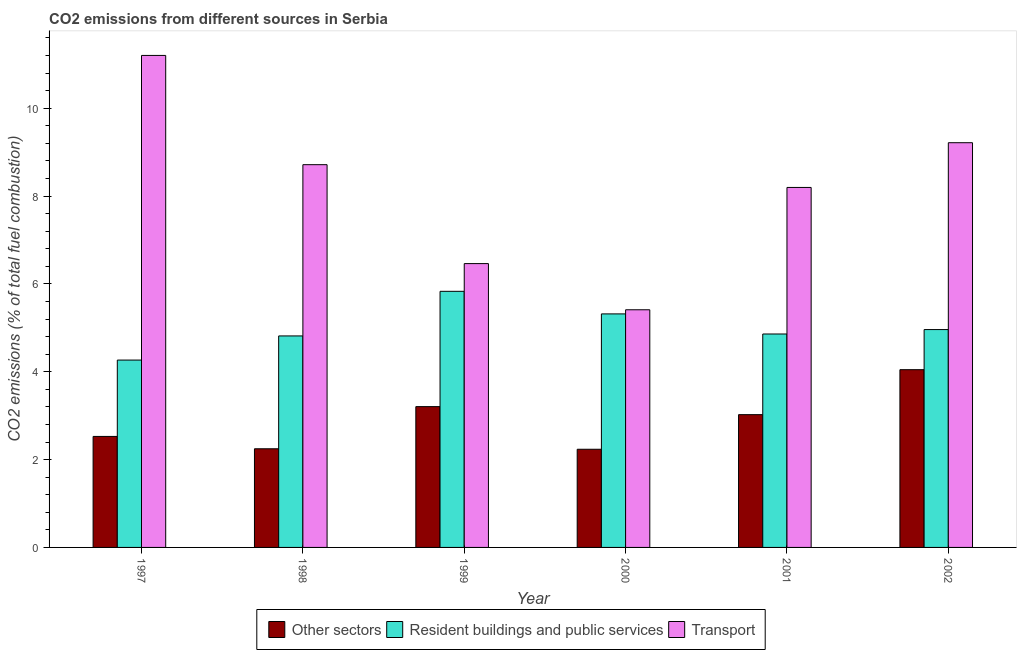Are the number of bars on each tick of the X-axis equal?
Keep it short and to the point. Yes. How many bars are there on the 6th tick from the left?
Your response must be concise. 3. How many bars are there on the 4th tick from the right?
Keep it short and to the point. 3. What is the label of the 1st group of bars from the left?
Provide a short and direct response. 1997. In how many cases, is the number of bars for a given year not equal to the number of legend labels?
Ensure brevity in your answer.  0. What is the percentage of co2 emissions from resident buildings and public services in 1999?
Provide a short and direct response. 5.83. Across all years, what is the maximum percentage of co2 emissions from resident buildings and public services?
Offer a terse response. 5.83. Across all years, what is the minimum percentage of co2 emissions from transport?
Ensure brevity in your answer.  5.41. In which year was the percentage of co2 emissions from transport maximum?
Ensure brevity in your answer.  1997. What is the total percentage of co2 emissions from other sectors in the graph?
Your answer should be very brief. 17.28. What is the difference between the percentage of co2 emissions from transport in 2000 and that in 2002?
Make the answer very short. -3.8. What is the difference between the percentage of co2 emissions from other sectors in 2000 and the percentage of co2 emissions from transport in 2002?
Make the answer very short. -1.81. What is the average percentage of co2 emissions from transport per year?
Offer a terse response. 8.2. In the year 2001, what is the difference between the percentage of co2 emissions from transport and percentage of co2 emissions from resident buildings and public services?
Provide a succinct answer. 0. In how many years, is the percentage of co2 emissions from resident buildings and public services greater than 1.6 %?
Offer a terse response. 6. What is the ratio of the percentage of co2 emissions from resident buildings and public services in 1998 to that in 2000?
Provide a short and direct response. 0.91. What is the difference between the highest and the second highest percentage of co2 emissions from transport?
Keep it short and to the point. 1.99. What is the difference between the highest and the lowest percentage of co2 emissions from resident buildings and public services?
Ensure brevity in your answer.  1.57. Is the sum of the percentage of co2 emissions from resident buildings and public services in 1997 and 2000 greater than the maximum percentage of co2 emissions from other sectors across all years?
Offer a terse response. Yes. What does the 2nd bar from the left in 2001 represents?
Offer a terse response. Resident buildings and public services. What does the 1st bar from the right in 1999 represents?
Ensure brevity in your answer.  Transport. Is it the case that in every year, the sum of the percentage of co2 emissions from other sectors and percentage of co2 emissions from resident buildings and public services is greater than the percentage of co2 emissions from transport?
Provide a short and direct response. No. How many bars are there?
Provide a succinct answer. 18. How many years are there in the graph?
Your answer should be compact. 6. Does the graph contain any zero values?
Make the answer very short. No. Where does the legend appear in the graph?
Keep it short and to the point. Bottom center. How many legend labels are there?
Make the answer very short. 3. What is the title of the graph?
Your answer should be compact. CO2 emissions from different sources in Serbia. What is the label or title of the X-axis?
Give a very brief answer. Year. What is the label or title of the Y-axis?
Make the answer very short. CO2 emissions (% of total fuel combustion). What is the CO2 emissions (% of total fuel combustion) of Other sectors in 1997?
Provide a short and direct response. 2.53. What is the CO2 emissions (% of total fuel combustion) of Resident buildings and public services in 1997?
Keep it short and to the point. 4.27. What is the CO2 emissions (% of total fuel combustion) of Transport in 1997?
Offer a terse response. 11.2. What is the CO2 emissions (% of total fuel combustion) of Other sectors in 1998?
Keep it short and to the point. 2.25. What is the CO2 emissions (% of total fuel combustion) in Resident buildings and public services in 1998?
Ensure brevity in your answer.  4.81. What is the CO2 emissions (% of total fuel combustion) of Transport in 1998?
Offer a very short reply. 8.71. What is the CO2 emissions (% of total fuel combustion) in Other sectors in 1999?
Give a very brief answer. 3.21. What is the CO2 emissions (% of total fuel combustion) in Resident buildings and public services in 1999?
Give a very brief answer. 5.83. What is the CO2 emissions (% of total fuel combustion) of Transport in 1999?
Keep it short and to the point. 6.46. What is the CO2 emissions (% of total fuel combustion) in Other sectors in 2000?
Provide a succinct answer. 2.23. What is the CO2 emissions (% of total fuel combustion) of Resident buildings and public services in 2000?
Keep it short and to the point. 5.32. What is the CO2 emissions (% of total fuel combustion) in Transport in 2000?
Provide a succinct answer. 5.41. What is the CO2 emissions (% of total fuel combustion) of Other sectors in 2001?
Provide a succinct answer. 3.02. What is the CO2 emissions (% of total fuel combustion) in Resident buildings and public services in 2001?
Your answer should be very brief. 4.86. What is the CO2 emissions (% of total fuel combustion) of Transport in 2001?
Make the answer very short. 8.2. What is the CO2 emissions (% of total fuel combustion) of Other sectors in 2002?
Ensure brevity in your answer.  4.05. What is the CO2 emissions (% of total fuel combustion) in Resident buildings and public services in 2002?
Ensure brevity in your answer.  4.96. What is the CO2 emissions (% of total fuel combustion) in Transport in 2002?
Offer a terse response. 9.21. Across all years, what is the maximum CO2 emissions (% of total fuel combustion) in Other sectors?
Make the answer very short. 4.05. Across all years, what is the maximum CO2 emissions (% of total fuel combustion) of Resident buildings and public services?
Provide a succinct answer. 5.83. Across all years, what is the maximum CO2 emissions (% of total fuel combustion) in Transport?
Your answer should be very brief. 11.2. Across all years, what is the minimum CO2 emissions (% of total fuel combustion) of Other sectors?
Your answer should be very brief. 2.23. Across all years, what is the minimum CO2 emissions (% of total fuel combustion) in Resident buildings and public services?
Offer a terse response. 4.27. Across all years, what is the minimum CO2 emissions (% of total fuel combustion) in Transport?
Give a very brief answer. 5.41. What is the total CO2 emissions (% of total fuel combustion) of Other sectors in the graph?
Your answer should be very brief. 17.28. What is the total CO2 emissions (% of total fuel combustion) in Resident buildings and public services in the graph?
Offer a terse response. 30.05. What is the total CO2 emissions (% of total fuel combustion) in Transport in the graph?
Your response must be concise. 49.2. What is the difference between the CO2 emissions (% of total fuel combustion) in Other sectors in 1997 and that in 1998?
Provide a short and direct response. 0.28. What is the difference between the CO2 emissions (% of total fuel combustion) in Resident buildings and public services in 1997 and that in 1998?
Give a very brief answer. -0.55. What is the difference between the CO2 emissions (% of total fuel combustion) in Transport in 1997 and that in 1998?
Make the answer very short. 2.49. What is the difference between the CO2 emissions (% of total fuel combustion) of Other sectors in 1997 and that in 1999?
Your answer should be compact. -0.68. What is the difference between the CO2 emissions (% of total fuel combustion) in Resident buildings and public services in 1997 and that in 1999?
Your answer should be very brief. -1.57. What is the difference between the CO2 emissions (% of total fuel combustion) in Transport in 1997 and that in 1999?
Give a very brief answer. 4.74. What is the difference between the CO2 emissions (% of total fuel combustion) of Other sectors in 1997 and that in 2000?
Keep it short and to the point. 0.29. What is the difference between the CO2 emissions (% of total fuel combustion) in Resident buildings and public services in 1997 and that in 2000?
Make the answer very short. -1.05. What is the difference between the CO2 emissions (% of total fuel combustion) in Transport in 1997 and that in 2000?
Offer a very short reply. 5.79. What is the difference between the CO2 emissions (% of total fuel combustion) in Other sectors in 1997 and that in 2001?
Provide a short and direct response. -0.5. What is the difference between the CO2 emissions (% of total fuel combustion) of Resident buildings and public services in 1997 and that in 2001?
Offer a very short reply. -0.59. What is the difference between the CO2 emissions (% of total fuel combustion) in Transport in 1997 and that in 2001?
Your answer should be compact. 3.01. What is the difference between the CO2 emissions (% of total fuel combustion) in Other sectors in 1997 and that in 2002?
Keep it short and to the point. -1.52. What is the difference between the CO2 emissions (% of total fuel combustion) of Resident buildings and public services in 1997 and that in 2002?
Make the answer very short. -0.69. What is the difference between the CO2 emissions (% of total fuel combustion) in Transport in 1997 and that in 2002?
Provide a succinct answer. 1.99. What is the difference between the CO2 emissions (% of total fuel combustion) in Other sectors in 1998 and that in 1999?
Your answer should be compact. -0.96. What is the difference between the CO2 emissions (% of total fuel combustion) of Resident buildings and public services in 1998 and that in 1999?
Make the answer very short. -1.02. What is the difference between the CO2 emissions (% of total fuel combustion) of Transport in 1998 and that in 1999?
Give a very brief answer. 2.25. What is the difference between the CO2 emissions (% of total fuel combustion) in Other sectors in 1998 and that in 2000?
Your response must be concise. 0.01. What is the difference between the CO2 emissions (% of total fuel combustion) of Resident buildings and public services in 1998 and that in 2000?
Give a very brief answer. -0.5. What is the difference between the CO2 emissions (% of total fuel combustion) of Transport in 1998 and that in 2000?
Your answer should be compact. 3.3. What is the difference between the CO2 emissions (% of total fuel combustion) in Other sectors in 1998 and that in 2001?
Make the answer very short. -0.78. What is the difference between the CO2 emissions (% of total fuel combustion) of Resident buildings and public services in 1998 and that in 2001?
Your answer should be compact. -0.04. What is the difference between the CO2 emissions (% of total fuel combustion) in Transport in 1998 and that in 2001?
Provide a succinct answer. 0.52. What is the difference between the CO2 emissions (% of total fuel combustion) of Other sectors in 1998 and that in 2002?
Offer a terse response. -1.8. What is the difference between the CO2 emissions (% of total fuel combustion) of Resident buildings and public services in 1998 and that in 2002?
Make the answer very short. -0.14. What is the difference between the CO2 emissions (% of total fuel combustion) in Transport in 1998 and that in 2002?
Your answer should be compact. -0.5. What is the difference between the CO2 emissions (% of total fuel combustion) of Other sectors in 1999 and that in 2000?
Make the answer very short. 0.97. What is the difference between the CO2 emissions (% of total fuel combustion) in Resident buildings and public services in 1999 and that in 2000?
Offer a very short reply. 0.51. What is the difference between the CO2 emissions (% of total fuel combustion) in Transport in 1999 and that in 2000?
Keep it short and to the point. 1.05. What is the difference between the CO2 emissions (% of total fuel combustion) of Other sectors in 1999 and that in 2001?
Ensure brevity in your answer.  0.18. What is the difference between the CO2 emissions (% of total fuel combustion) of Resident buildings and public services in 1999 and that in 2001?
Your answer should be compact. 0.97. What is the difference between the CO2 emissions (% of total fuel combustion) of Transport in 1999 and that in 2001?
Your response must be concise. -1.73. What is the difference between the CO2 emissions (% of total fuel combustion) in Other sectors in 1999 and that in 2002?
Provide a short and direct response. -0.84. What is the difference between the CO2 emissions (% of total fuel combustion) of Resident buildings and public services in 1999 and that in 2002?
Keep it short and to the point. 0.87. What is the difference between the CO2 emissions (% of total fuel combustion) in Transport in 1999 and that in 2002?
Provide a succinct answer. -2.75. What is the difference between the CO2 emissions (% of total fuel combustion) in Other sectors in 2000 and that in 2001?
Give a very brief answer. -0.79. What is the difference between the CO2 emissions (% of total fuel combustion) in Resident buildings and public services in 2000 and that in 2001?
Offer a terse response. 0.46. What is the difference between the CO2 emissions (% of total fuel combustion) of Transport in 2000 and that in 2001?
Give a very brief answer. -2.78. What is the difference between the CO2 emissions (% of total fuel combustion) in Other sectors in 2000 and that in 2002?
Your response must be concise. -1.81. What is the difference between the CO2 emissions (% of total fuel combustion) of Resident buildings and public services in 2000 and that in 2002?
Offer a very short reply. 0.36. What is the difference between the CO2 emissions (% of total fuel combustion) of Transport in 2000 and that in 2002?
Make the answer very short. -3.8. What is the difference between the CO2 emissions (% of total fuel combustion) in Other sectors in 2001 and that in 2002?
Your answer should be very brief. -1.02. What is the difference between the CO2 emissions (% of total fuel combustion) of Resident buildings and public services in 2001 and that in 2002?
Your response must be concise. -0.1. What is the difference between the CO2 emissions (% of total fuel combustion) in Transport in 2001 and that in 2002?
Provide a short and direct response. -1.02. What is the difference between the CO2 emissions (% of total fuel combustion) in Other sectors in 1997 and the CO2 emissions (% of total fuel combustion) in Resident buildings and public services in 1998?
Your response must be concise. -2.29. What is the difference between the CO2 emissions (% of total fuel combustion) in Other sectors in 1997 and the CO2 emissions (% of total fuel combustion) in Transport in 1998?
Offer a very short reply. -6.19. What is the difference between the CO2 emissions (% of total fuel combustion) in Resident buildings and public services in 1997 and the CO2 emissions (% of total fuel combustion) in Transport in 1998?
Your response must be concise. -4.45. What is the difference between the CO2 emissions (% of total fuel combustion) of Other sectors in 1997 and the CO2 emissions (% of total fuel combustion) of Resident buildings and public services in 1999?
Offer a very short reply. -3.3. What is the difference between the CO2 emissions (% of total fuel combustion) of Other sectors in 1997 and the CO2 emissions (% of total fuel combustion) of Transport in 1999?
Offer a terse response. -3.93. What is the difference between the CO2 emissions (% of total fuel combustion) in Resident buildings and public services in 1997 and the CO2 emissions (% of total fuel combustion) in Transport in 1999?
Ensure brevity in your answer.  -2.2. What is the difference between the CO2 emissions (% of total fuel combustion) in Other sectors in 1997 and the CO2 emissions (% of total fuel combustion) in Resident buildings and public services in 2000?
Your answer should be very brief. -2.79. What is the difference between the CO2 emissions (% of total fuel combustion) of Other sectors in 1997 and the CO2 emissions (% of total fuel combustion) of Transport in 2000?
Offer a terse response. -2.88. What is the difference between the CO2 emissions (% of total fuel combustion) in Resident buildings and public services in 1997 and the CO2 emissions (% of total fuel combustion) in Transport in 2000?
Offer a very short reply. -1.15. What is the difference between the CO2 emissions (% of total fuel combustion) of Other sectors in 1997 and the CO2 emissions (% of total fuel combustion) of Resident buildings and public services in 2001?
Keep it short and to the point. -2.33. What is the difference between the CO2 emissions (% of total fuel combustion) of Other sectors in 1997 and the CO2 emissions (% of total fuel combustion) of Transport in 2001?
Your answer should be very brief. -5.67. What is the difference between the CO2 emissions (% of total fuel combustion) in Resident buildings and public services in 1997 and the CO2 emissions (% of total fuel combustion) in Transport in 2001?
Your answer should be compact. -3.93. What is the difference between the CO2 emissions (% of total fuel combustion) in Other sectors in 1997 and the CO2 emissions (% of total fuel combustion) in Resident buildings and public services in 2002?
Offer a terse response. -2.43. What is the difference between the CO2 emissions (% of total fuel combustion) in Other sectors in 1997 and the CO2 emissions (% of total fuel combustion) in Transport in 2002?
Keep it short and to the point. -6.69. What is the difference between the CO2 emissions (% of total fuel combustion) in Resident buildings and public services in 1997 and the CO2 emissions (% of total fuel combustion) in Transport in 2002?
Offer a very short reply. -4.95. What is the difference between the CO2 emissions (% of total fuel combustion) of Other sectors in 1998 and the CO2 emissions (% of total fuel combustion) of Resident buildings and public services in 1999?
Give a very brief answer. -3.58. What is the difference between the CO2 emissions (% of total fuel combustion) of Other sectors in 1998 and the CO2 emissions (% of total fuel combustion) of Transport in 1999?
Your answer should be compact. -4.22. What is the difference between the CO2 emissions (% of total fuel combustion) in Resident buildings and public services in 1998 and the CO2 emissions (% of total fuel combustion) in Transport in 1999?
Your answer should be very brief. -1.65. What is the difference between the CO2 emissions (% of total fuel combustion) in Other sectors in 1998 and the CO2 emissions (% of total fuel combustion) in Resident buildings and public services in 2000?
Offer a very short reply. -3.07. What is the difference between the CO2 emissions (% of total fuel combustion) of Other sectors in 1998 and the CO2 emissions (% of total fuel combustion) of Transport in 2000?
Provide a succinct answer. -3.16. What is the difference between the CO2 emissions (% of total fuel combustion) in Resident buildings and public services in 1998 and the CO2 emissions (% of total fuel combustion) in Transport in 2000?
Offer a very short reply. -0.6. What is the difference between the CO2 emissions (% of total fuel combustion) of Other sectors in 1998 and the CO2 emissions (% of total fuel combustion) of Resident buildings and public services in 2001?
Your answer should be compact. -2.61. What is the difference between the CO2 emissions (% of total fuel combustion) of Other sectors in 1998 and the CO2 emissions (% of total fuel combustion) of Transport in 2001?
Offer a very short reply. -5.95. What is the difference between the CO2 emissions (% of total fuel combustion) of Resident buildings and public services in 1998 and the CO2 emissions (% of total fuel combustion) of Transport in 2001?
Your response must be concise. -3.38. What is the difference between the CO2 emissions (% of total fuel combustion) of Other sectors in 1998 and the CO2 emissions (% of total fuel combustion) of Resident buildings and public services in 2002?
Give a very brief answer. -2.71. What is the difference between the CO2 emissions (% of total fuel combustion) of Other sectors in 1998 and the CO2 emissions (% of total fuel combustion) of Transport in 2002?
Your answer should be compact. -6.97. What is the difference between the CO2 emissions (% of total fuel combustion) in Resident buildings and public services in 1998 and the CO2 emissions (% of total fuel combustion) in Transport in 2002?
Offer a very short reply. -4.4. What is the difference between the CO2 emissions (% of total fuel combustion) of Other sectors in 1999 and the CO2 emissions (% of total fuel combustion) of Resident buildings and public services in 2000?
Your answer should be compact. -2.11. What is the difference between the CO2 emissions (% of total fuel combustion) of Other sectors in 1999 and the CO2 emissions (% of total fuel combustion) of Transport in 2000?
Offer a very short reply. -2.21. What is the difference between the CO2 emissions (% of total fuel combustion) in Resident buildings and public services in 1999 and the CO2 emissions (% of total fuel combustion) in Transport in 2000?
Give a very brief answer. 0.42. What is the difference between the CO2 emissions (% of total fuel combustion) of Other sectors in 1999 and the CO2 emissions (% of total fuel combustion) of Resident buildings and public services in 2001?
Provide a succinct answer. -1.65. What is the difference between the CO2 emissions (% of total fuel combustion) of Other sectors in 1999 and the CO2 emissions (% of total fuel combustion) of Transport in 2001?
Offer a very short reply. -4.99. What is the difference between the CO2 emissions (% of total fuel combustion) in Resident buildings and public services in 1999 and the CO2 emissions (% of total fuel combustion) in Transport in 2001?
Keep it short and to the point. -2.36. What is the difference between the CO2 emissions (% of total fuel combustion) of Other sectors in 1999 and the CO2 emissions (% of total fuel combustion) of Resident buildings and public services in 2002?
Your answer should be very brief. -1.75. What is the difference between the CO2 emissions (% of total fuel combustion) in Other sectors in 1999 and the CO2 emissions (% of total fuel combustion) in Transport in 2002?
Give a very brief answer. -6.01. What is the difference between the CO2 emissions (% of total fuel combustion) of Resident buildings and public services in 1999 and the CO2 emissions (% of total fuel combustion) of Transport in 2002?
Provide a succinct answer. -3.38. What is the difference between the CO2 emissions (% of total fuel combustion) of Other sectors in 2000 and the CO2 emissions (% of total fuel combustion) of Resident buildings and public services in 2001?
Offer a terse response. -2.62. What is the difference between the CO2 emissions (% of total fuel combustion) of Other sectors in 2000 and the CO2 emissions (% of total fuel combustion) of Transport in 2001?
Offer a very short reply. -5.96. What is the difference between the CO2 emissions (% of total fuel combustion) of Resident buildings and public services in 2000 and the CO2 emissions (% of total fuel combustion) of Transport in 2001?
Provide a short and direct response. -2.88. What is the difference between the CO2 emissions (% of total fuel combustion) in Other sectors in 2000 and the CO2 emissions (% of total fuel combustion) in Resident buildings and public services in 2002?
Ensure brevity in your answer.  -2.72. What is the difference between the CO2 emissions (% of total fuel combustion) in Other sectors in 2000 and the CO2 emissions (% of total fuel combustion) in Transport in 2002?
Provide a short and direct response. -6.98. What is the difference between the CO2 emissions (% of total fuel combustion) of Resident buildings and public services in 2000 and the CO2 emissions (% of total fuel combustion) of Transport in 2002?
Your response must be concise. -3.9. What is the difference between the CO2 emissions (% of total fuel combustion) of Other sectors in 2001 and the CO2 emissions (% of total fuel combustion) of Resident buildings and public services in 2002?
Give a very brief answer. -1.94. What is the difference between the CO2 emissions (% of total fuel combustion) of Other sectors in 2001 and the CO2 emissions (% of total fuel combustion) of Transport in 2002?
Ensure brevity in your answer.  -6.19. What is the difference between the CO2 emissions (% of total fuel combustion) in Resident buildings and public services in 2001 and the CO2 emissions (% of total fuel combustion) in Transport in 2002?
Provide a short and direct response. -4.35. What is the average CO2 emissions (% of total fuel combustion) in Other sectors per year?
Provide a short and direct response. 2.88. What is the average CO2 emissions (% of total fuel combustion) in Resident buildings and public services per year?
Provide a succinct answer. 5.01. What is the average CO2 emissions (% of total fuel combustion) in Transport per year?
Your answer should be compact. 8.2. In the year 1997, what is the difference between the CO2 emissions (% of total fuel combustion) of Other sectors and CO2 emissions (% of total fuel combustion) of Resident buildings and public services?
Ensure brevity in your answer.  -1.74. In the year 1997, what is the difference between the CO2 emissions (% of total fuel combustion) of Other sectors and CO2 emissions (% of total fuel combustion) of Transport?
Provide a short and direct response. -8.67. In the year 1997, what is the difference between the CO2 emissions (% of total fuel combustion) in Resident buildings and public services and CO2 emissions (% of total fuel combustion) in Transport?
Your answer should be very brief. -6.94. In the year 1998, what is the difference between the CO2 emissions (% of total fuel combustion) of Other sectors and CO2 emissions (% of total fuel combustion) of Resident buildings and public services?
Provide a short and direct response. -2.57. In the year 1998, what is the difference between the CO2 emissions (% of total fuel combustion) of Other sectors and CO2 emissions (% of total fuel combustion) of Transport?
Offer a very short reply. -6.47. In the year 1998, what is the difference between the CO2 emissions (% of total fuel combustion) of Resident buildings and public services and CO2 emissions (% of total fuel combustion) of Transport?
Provide a succinct answer. -3.9. In the year 1999, what is the difference between the CO2 emissions (% of total fuel combustion) of Other sectors and CO2 emissions (% of total fuel combustion) of Resident buildings and public services?
Keep it short and to the point. -2.62. In the year 1999, what is the difference between the CO2 emissions (% of total fuel combustion) in Other sectors and CO2 emissions (% of total fuel combustion) in Transport?
Your answer should be compact. -3.26. In the year 1999, what is the difference between the CO2 emissions (% of total fuel combustion) in Resident buildings and public services and CO2 emissions (% of total fuel combustion) in Transport?
Offer a terse response. -0.63. In the year 2000, what is the difference between the CO2 emissions (% of total fuel combustion) in Other sectors and CO2 emissions (% of total fuel combustion) in Resident buildings and public services?
Make the answer very short. -3.08. In the year 2000, what is the difference between the CO2 emissions (% of total fuel combustion) of Other sectors and CO2 emissions (% of total fuel combustion) of Transport?
Offer a terse response. -3.18. In the year 2000, what is the difference between the CO2 emissions (% of total fuel combustion) in Resident buildings and public services and CO2 emissions (% of total fuel combustion) in Transport?
Offer a terse response. -0.09. In the year 2001, what is the difference between the CO2 emissions (% of total fuel combustion) of Other sectors and CO2 emissions (% of total fuel combustion) of Resident buildings and public services?
Offer a terse response. -1.84. In the year 2001, what is the difference between the CO2 emissions (% of total fuel combustion) of Other sectors and CO2 emissions (% of total fuel combustion) of Transport?
Provide a short and direct response. -5.17. In the year 2001, what is the difference between the CO2 emissions (% of total fuel combustion) in Resident buildings and public services and CO2 emissions (% of total fuel combustion) in Transport?
Make the answer very short. -3.34. In the year 2002, what is the difference between the CO2 emissions (% of total fuel combustion) of Other sectors and CO2 emissions (% of total fuel combustion) of Resident buildings and public services?
Offer a very short reply. -0.91. In the year 2002, what is the difference between the CO2 emissions (% of total fuel combustion) of Other sectors and CO2 emissions (% of total fuel combustion) of Transport?
Your answer should be compact. -5.17. In the year 2002, what is the difference between the CO2 emissions (% of total fuel combustion) of Resident buildings and public services and CO2 emissions (% of total fuel combustion) of Transport?
Give a very brief answer. -4.25. What is the ratio of the CO2 emissions (% of total fuel combustion) of Other sectors in 1997 to that in 1998?
Offer a very short reply. 1.13. What is the ratio of the CO2 emissions (% of total fuel combustion) of Resident buildings and public services in 1997 to that in 1998?
Ensure brevity in your answer.  0.89. What is the ratio of the CO2 emissions (% of total fuel combustion) of Transport in 1997 to that in 1998?
Your answer should be very brief. 1.29. What is the ratio of the CO2 emissions (% of total fuel combustion) in Other sectors in 1997 to that in 1999?
Provide a short and direct response. 0.79. What is the ratio of the CO2 emissions (% of total fuel combustion) of Resident buildings and public services in 1997 to that in 1999?
Keep it short and to the point. 0.73. What is the ratio of the CO2 emissions (% of total fuel combustion) of Transport in 1997 to that in 1999?
Offer a terse response. 1.73. What is the ratio of the CO2 emissions (% of total fuel combustion) in Other sectors in 1997 to that in 2000?
Your answer should be very brief. 1.13. What is the ratio of the CO2 emissions (% of total fuel combustion) in Resident buildings and public services in 1997 to that in 2000?
Ensure brevity in your answer.  0.8. What is the ratio of the CO2 emissions (% of total fuel combustion) in Transport in 1997 to that in 2000?
Ensure brevity in your answer.  2.07. What is the ratio of the CO2 emissions (% of total fuel combustion) of Other sectors in 1997 to that in 2001?
Your answer should be very brief. 0.84. What is the ratio of the CO2 emissions (% of total fuel combustion) of Resident buildings and public services in 1997 to that in 2001?
Provide a succinct answer. 0.88. What is the ratio of the CO2 emissions (% of total fuel combustion) in Transport in 1997 to that in 2001?
Provide a succinct answer. 1.37. What is the ratio of the CO2 emissions (% of total fuel combustion) of Other sectors in 1997 to that in 2002?
Ensure brevity in your answer.  0.62. What is the ratio of the CO2 emissions (% of total fuel combustion) in Resident buildings and public services in 1997 to that in 2002?
Keep it short and to the point. 0.86. What is the ratio of the CO2 emissions (% of total fuel combustion) in Transport in 1997 to that in 2002?
Ensure brevity in your answer.  1.22. What is the ratio of the CO2 emissions (% of total fuel combustion) of Other sectors in 1998 to that in 1999?
Offer a terse response. 0.7. What is the ratio of the CO2 emissions (% of total fuel combustion) of Resident buildings and public services in 1998 to that in 1999?
Make the answer very short. 0.83. What is the ratio of the CO2 emissions (% of total fuel combustion) of Transport in 1998 to that in 1999?
Your answer should be very brief. 1.35. What is the ratio of the CO2 emissions (% of total fuel combustion) in Resident buildings and public services in 1998 to that in 2000?
Provide a short and direct response. 0.91. What is the ratio of the CO2 emissions (% of total fuel combustion) of Transport in 1998 to that in 2000?
Offer a terse response. 1.61. What is the ratio of the CO2 emissions (% of total fuel combustion) in Other sectors in 1998 to that in 2001?
Offer a very short reply. 0.74. What is the ratio of the CO2 emissions (% of total fuel combustion) of Resident buildings and public services in 1998 to that in 2001?
Offer a terse response. 0.99. What is the ratio of the CO2 emissions (% of total fuel combustion) of Transport in 1998 to that in 2001?
Keep it short and to the point. 1.06. What is the ratio of the CO2 emissions (% of total fuel combustion) in Other sectors in 1998 to that in 2002?
Keep it short and to the point. 0.56. What is the ratio of the CO2 emissions (% of total fuel combustion) of Resident buildings and public services in 1998 to that in 2002?
Offer a very short reply. 0.97. What is the ratio of the CO2 emissions (% of total fuel combustion) in Transport in 1998 to that in 2002?
Ensure brevity in your answer.  0.95. What is the ratio of the CO2 emissions (% of total fuel combustion) of Other sectors in 1999 to that in 2000?
Offer a very short reply. 1.43. What is the ratio of the CO2 emissions (% of total fuel combustion) in Resident buildings and public services in 1999 to that in 2000?
Offer a very short reply. 1.1. What is the ratio of the CO2 emissions (% of total fuel combustion) of Transport in 1999 to that in 2000?
Provide a succinct answer. 1.19. What is the ratio of the CO2 emissions (% of total fuel combustion) in Other sectors in 1999 to that in 2001?
Offer a very short reply. 1.06. What is the ratio of the CO2 emissions (% of total fuel combustion) of Resident buildings and public services in 1999 to that in 2001?
Your answer should be very brief. 1.2. What is the ratio of the CO2 emissions (% of total fuel combustion) in Transport in 1999 to that in 2001?
Provide a short and direct response. 0.79. What is the ratio of the CO2 emissions (% of total fuel combustion) in Other sectors in 1999 to that in 2002?
Provide a short and direct response. 0.79. What is the ratio of the CO2 emissions (% of total fuel combustion) of Resident buildings and public services in 1999 to that in 2002?
Provide a succinct answer. 1.18. What is the ratio of the CO2 emissions (% of total fuel combustion) of Transport in 1999 to that in 2002?
Make the answer very short. 0.7. What is the ratio of the CO2 emissions (% of total fuel combustion) of Other sectors in 2000 to that in 2001?
Ensure brevity in your answer.  0.74. What is the ratio of the CO2 emissions (% of total fuel combustion) of Resident buildings and public services in 2000 to that in 2001?
Make the answer very short. 1.09. What is the ratio of the CO2 emissions (% of total fuel combustion) in Transport in 2000 to that in 2001?
Give a very brief answer. 0.66. What is the ratio of the CO2 emissions (% of total fuel combustion) of Other sectors in 2000 to that in 2002?
Give a very brief answer. 0.55. What is the ratio of the CO2 emissions (% of total fuel combustion) in Resident buildings and public services in 2000 to that in 2002?
Give a very brief answer. 1.07. What is the ratio of the CO2 emissions (% of total fuel combustion) of Transport in 2000 to that in 2002?
Provide a succinct answer. 0.59. What is the ratio of the CO2 emissions (% of total fuel combustion) in Other sectors in 2001 to that in 2002?
Your answer should be compact. 0.75. What is the ratio of the CO2 emissions (% of total fuel combustion) in Resident buildings and public services in 2001 to that in 2002?
Offer a terse response. 0.98. What is the ratio of the CO2 emissions (% of total fuel combustion) in Transport in 2001 to that in 2002?
Your response must be concise. 0.89. What is the difference between the highest and the second highest CO2 emissions (% of total fuel combustion) in Other sectors?
Your response must be concise. 0.84. What is the difference between the highest and the second highest CO2 emissions (% of total fuel combustion) in Resident buildings and public services?
Your answer should be very brief. 0.51. What is the difference between the highest and the second highest CO2 emissions (% of total fuel combustion) in Transport?
Your response must be concise. 1.99. What is the difference between the highest and the lowest CO2 emissions (% of total fuel combustion) in Other sectors?
Keep it short and to the point. 1.81. What is the difference between the highest and the lowest CO2 emissions (% of total fuel combustion) of Resident buildings and public services?
Offer a terse response. 1.57. What is the difference between the highest and the lowest CO2 emissions (% of total fuel combustion) of Transport?
Ensure brevity in your answer.  5.79. 